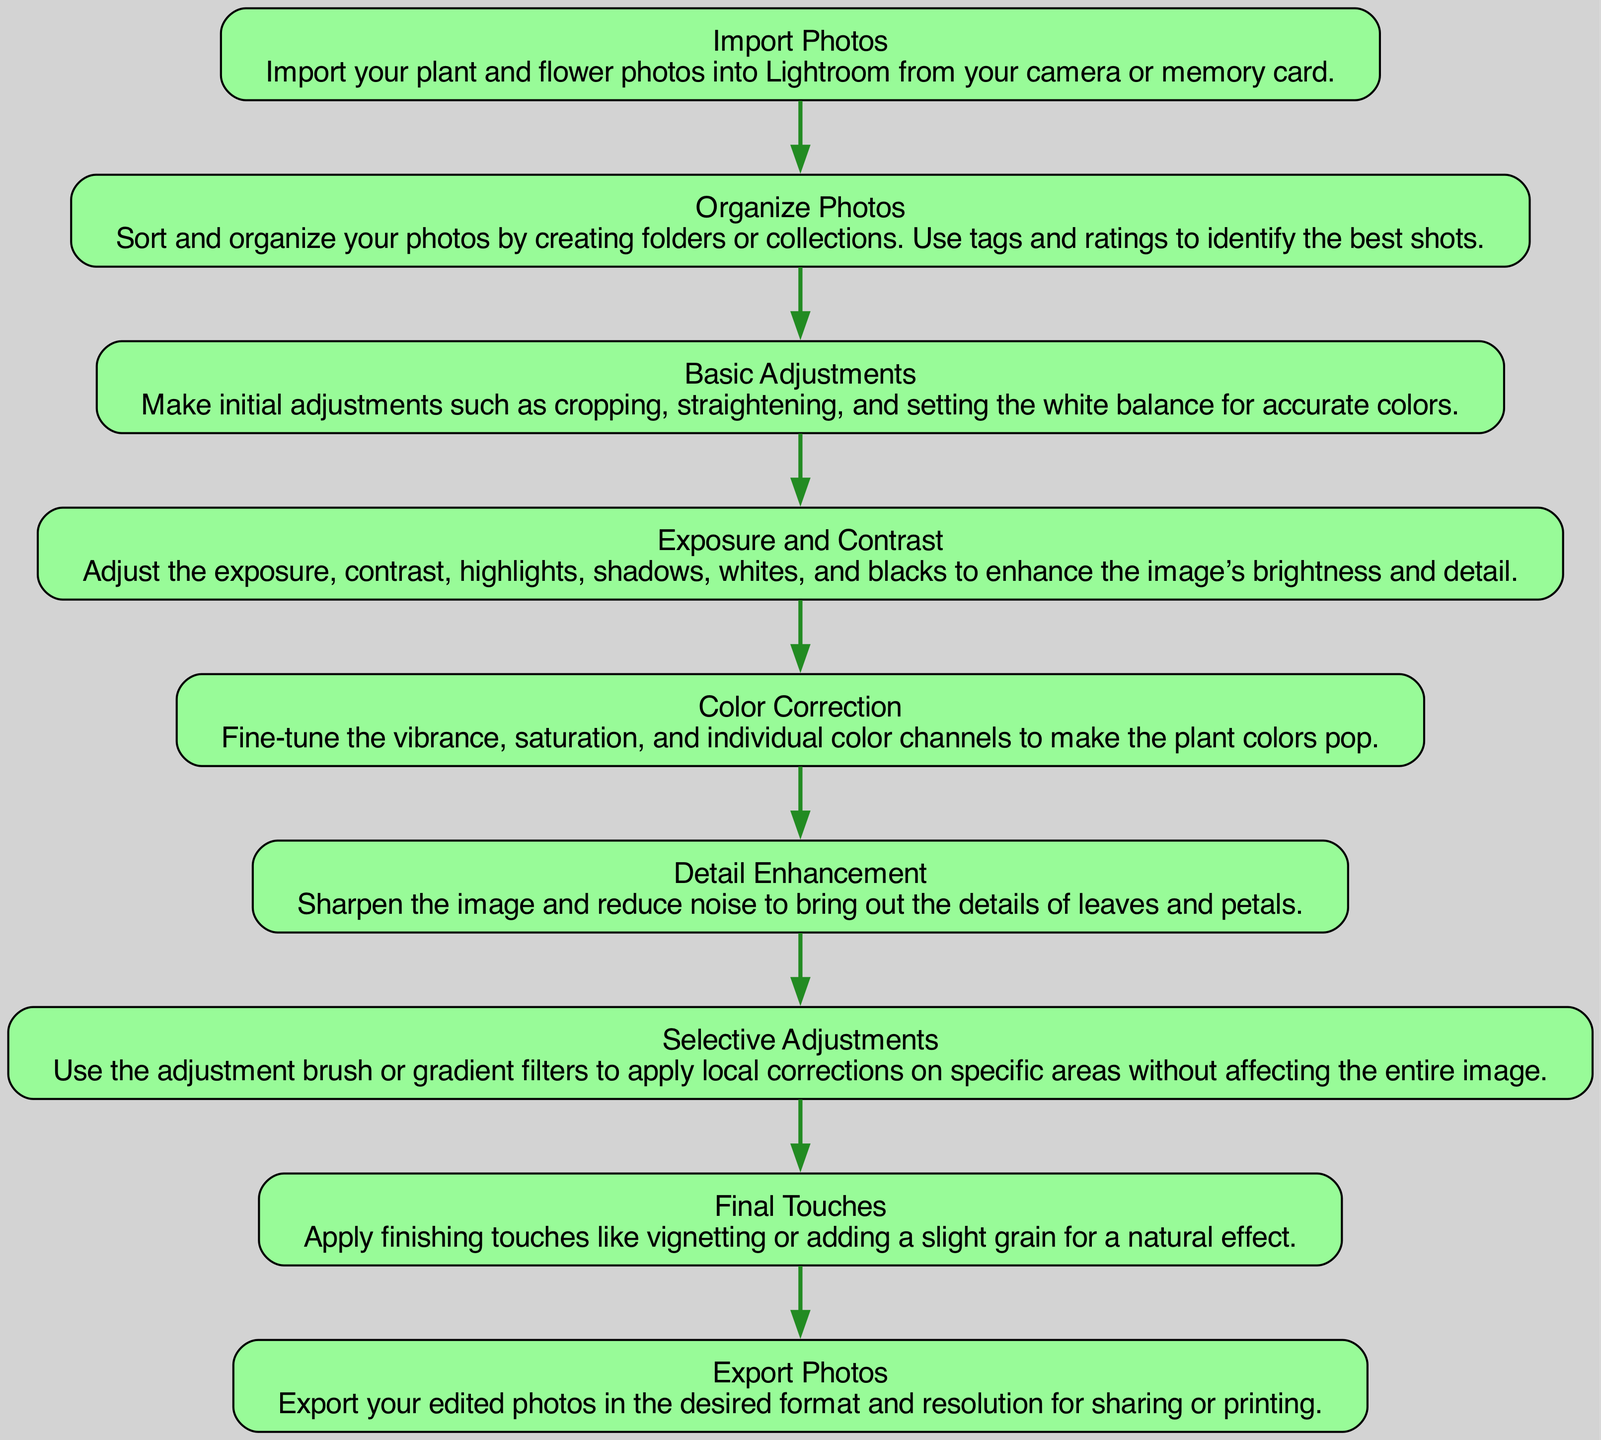What is the first step in editing plant photos? The first step, as shown in the diagram, is "Import Photos." This is the starting point of the workflow for editing.
Answer: Import Photos What comes after "Color Correction"? After "Color Correction," the next step indicated in the diagram is "Detail Enhancement." This follows logically in the editing process.
Answer: Detail Enhancement How many steps are there in total? There are eight steps illustrated in the diagram, each leading to the next in the editing workflow.
Answer: Eight What type of adjustments does "Selective Adjustments" involve? "Selective Adjustments" involves using the adjustment brush or gradient filters for local corrections, which means adjustments are made on specific areas rather than the entire image.
Answer: Local corrections What is the last step in the editing process? The last step in the process is "Export Photos," which indicates that the final action is to save the edited images in a desired format for sharing or printing.
Answer: Export Photos Which step includes adjusting the vibrance? The step that includes adjusting vibrance is "Color Correction," where fine-tuning the saturation and individual color channels is performed to enhance the colors.
Answer: Color Correction Which steps are directly connected to "Basic Adjustments"? "Basic Adjustments" is directly connected to "Exposure and Contrast." The flow indicates that after making initial adjustments, users proceed to refine exposure and contrast.
Answer: Exposure and Contrast What is the purpose of "Final Touches"? The purpose of "Final Touches" is to apply finishing details to the photo, such as vignetting or adding grain, which enhance the overall appearance of the image.
Answer: Enhance appearance 